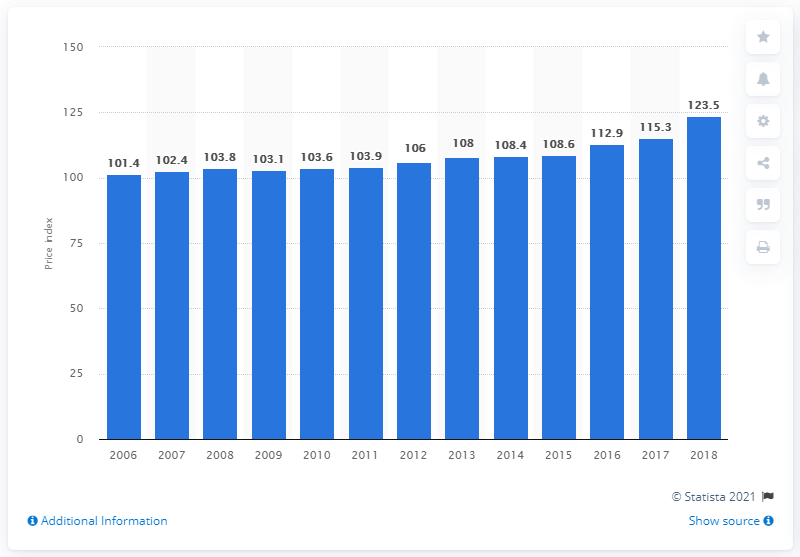Identify some key points in this picture. The producer price index of hardwood veneer and plywood in 2018 was 123.5. 